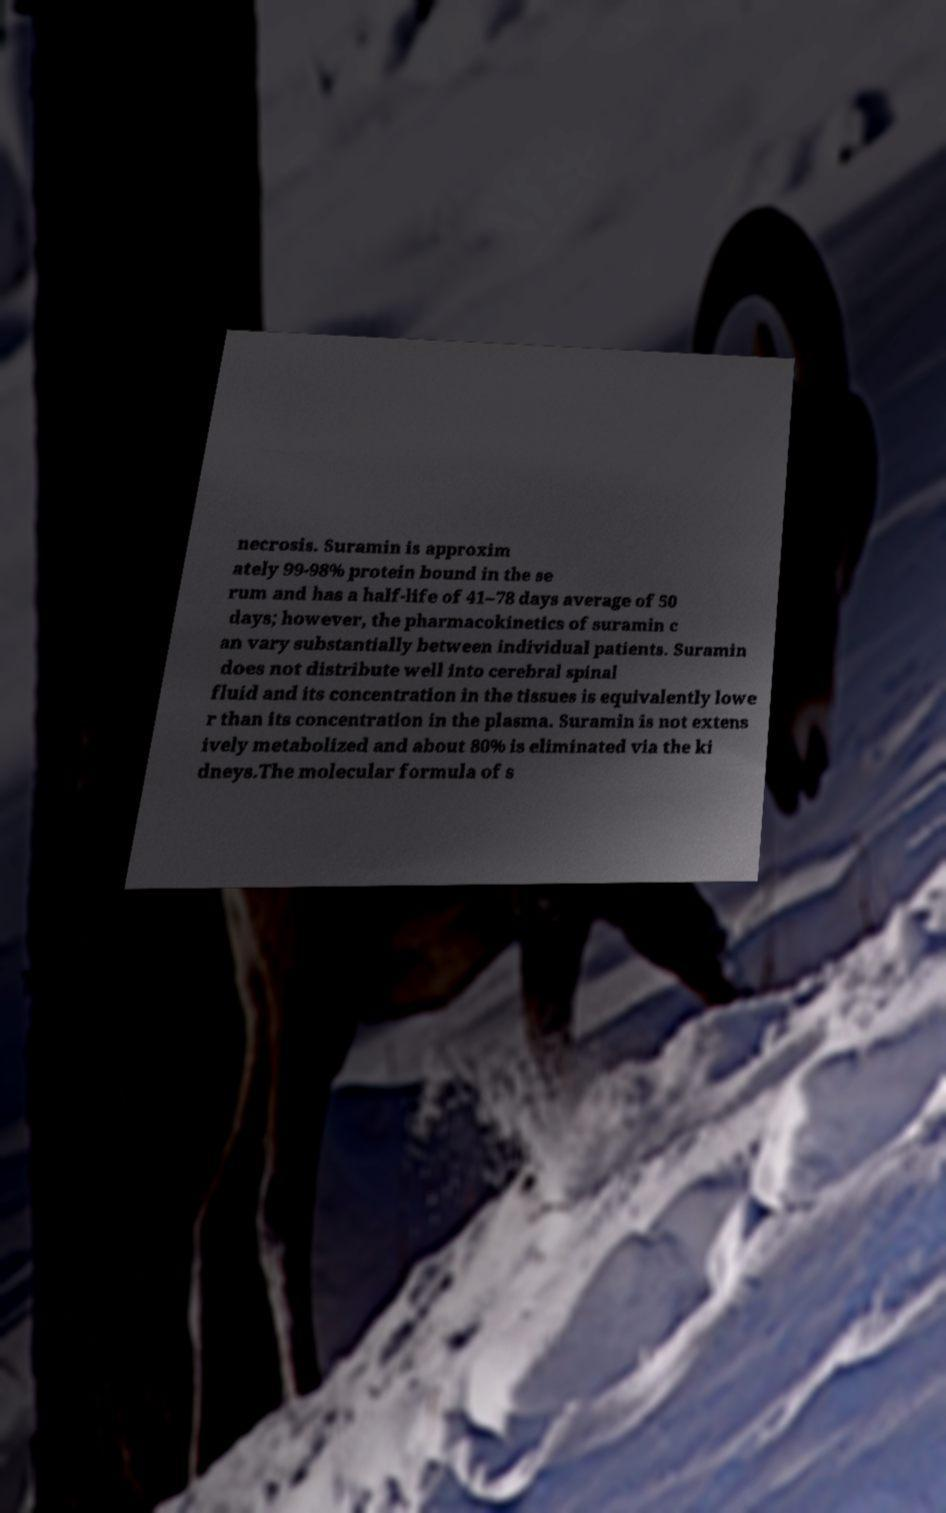Can you accurately transcribe the text from the provided image for me? necrosis. Suramin is approxim ately 99-98% protein bound in the se rum and has a half-life of 41–78 days average of 50 days; however, the pharmacokinetics of suramin c an vary substantially between individual patients. Suramin does not distribute well into cerebral spinal fluid and its concentration in the tissues is equivalently lowe r than its concentration in the plasma. Suramin is not extens ively metabolized and about 80% is eliminated via the ki dneys.The molecular formula of s 